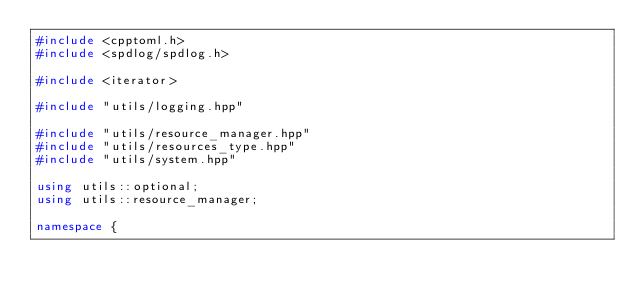<code> <loc_0><loc_0><loc_500><loc_500><_C++_>#include <cpptoml.h>
#include <spdlog/spdlog.h>

#include <iterator>

#include "utils/logging.hpp"

#include "utils/resource_manager.hpp"
#include "utils/resources_type.hpp"
#include "utils/system.hpp"

using utils::optional;
using utils::resource_manager;

namespace {</code> 